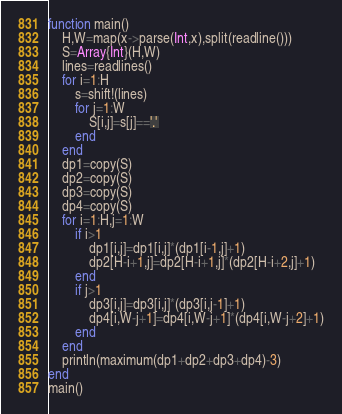Convert code to text. <code><loc_0><loc_0><loc_500><loc_500><_Julia_>function main()
	H,W=map(x->parse(Int,x),split(readline()))
	S=Array{Int}(H,W)
	lines=readlines()
	for i=1:H
		s=shift!(lines)
		for j=1:W
			S[i,j]=s[j]=='.'
		end
	end
	dp1=copy(S)
	dp2=copy(S)
	dp3=copy(S)
	dp4=copy(S)
	for i=1:H,j=1:W
		if i>1
			dp1[i,j]=dp1[i,j]*(dp1[i-1,j]+1)
			dp2[H-i+1,j]=dp2[H-i+1,j]*(dp2[H-i+2,j]+1)
		end
		if j>1
			dp3[i,j]=dp3[i,j]*(dp3[i,j-1]+1)
			dp4[i,W-j+1]=dp4[i,W-j+1]*(dp4[i,W-j+2]+1)
		end
	end
	println(maximum(dp1+dp2+dp3+dp4)-3)
end
main()
</code> 